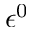Convert formula to latex. <formula><loc_0><loc_0><loc_500><loc_500>\epsilon ^ { 0 }</formula> 